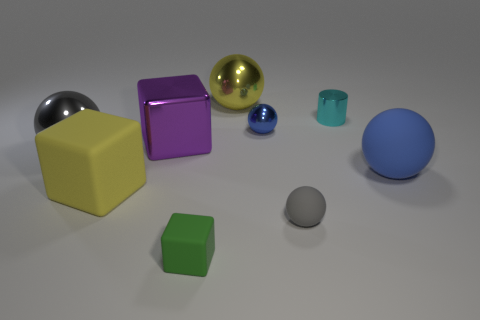Do the big thing right of the yellow metal thing and the small metallic ball have the same color?
Your answer should be very brief. Yes. Do the tiny matte sphere and the big metal sphere in front of the small cyan shiny cylinder have the same color?
Make the answer very short. Yes. The rubber sphere that is the same color as the small metal sphere is what size?
Provide a short and direct response. Large. Are there any large yellow things that are in front of the large shiny ball that is to the right of the yellow thing that is in front of the big metal cube?
Your response must be concise. Yes. What is the color of the other ball that is the same size as the blue shiny ball?
Provide a succinct answer. Gray. There is a big metal thing that is both in front of the big yellow metal object and to the right of the yellow matte block; what shape is it?
Provide a succinct answer. Cube. There is a blue sphere that is in front of the gray ball on the left side of the tiny green block; how big is it?
Your answer should be very brief. Large. What number of other matte balls are the same color as the small rubber ball?
Provide a succinct answer. 0. What number of other objects are there of the same size as the blue matte sphere?
Provide a succinct answer. 4. What size is the object that is both on the right side of the tiny gray matte object and in front of the shiny block?
Your answer should be compact. Large. 